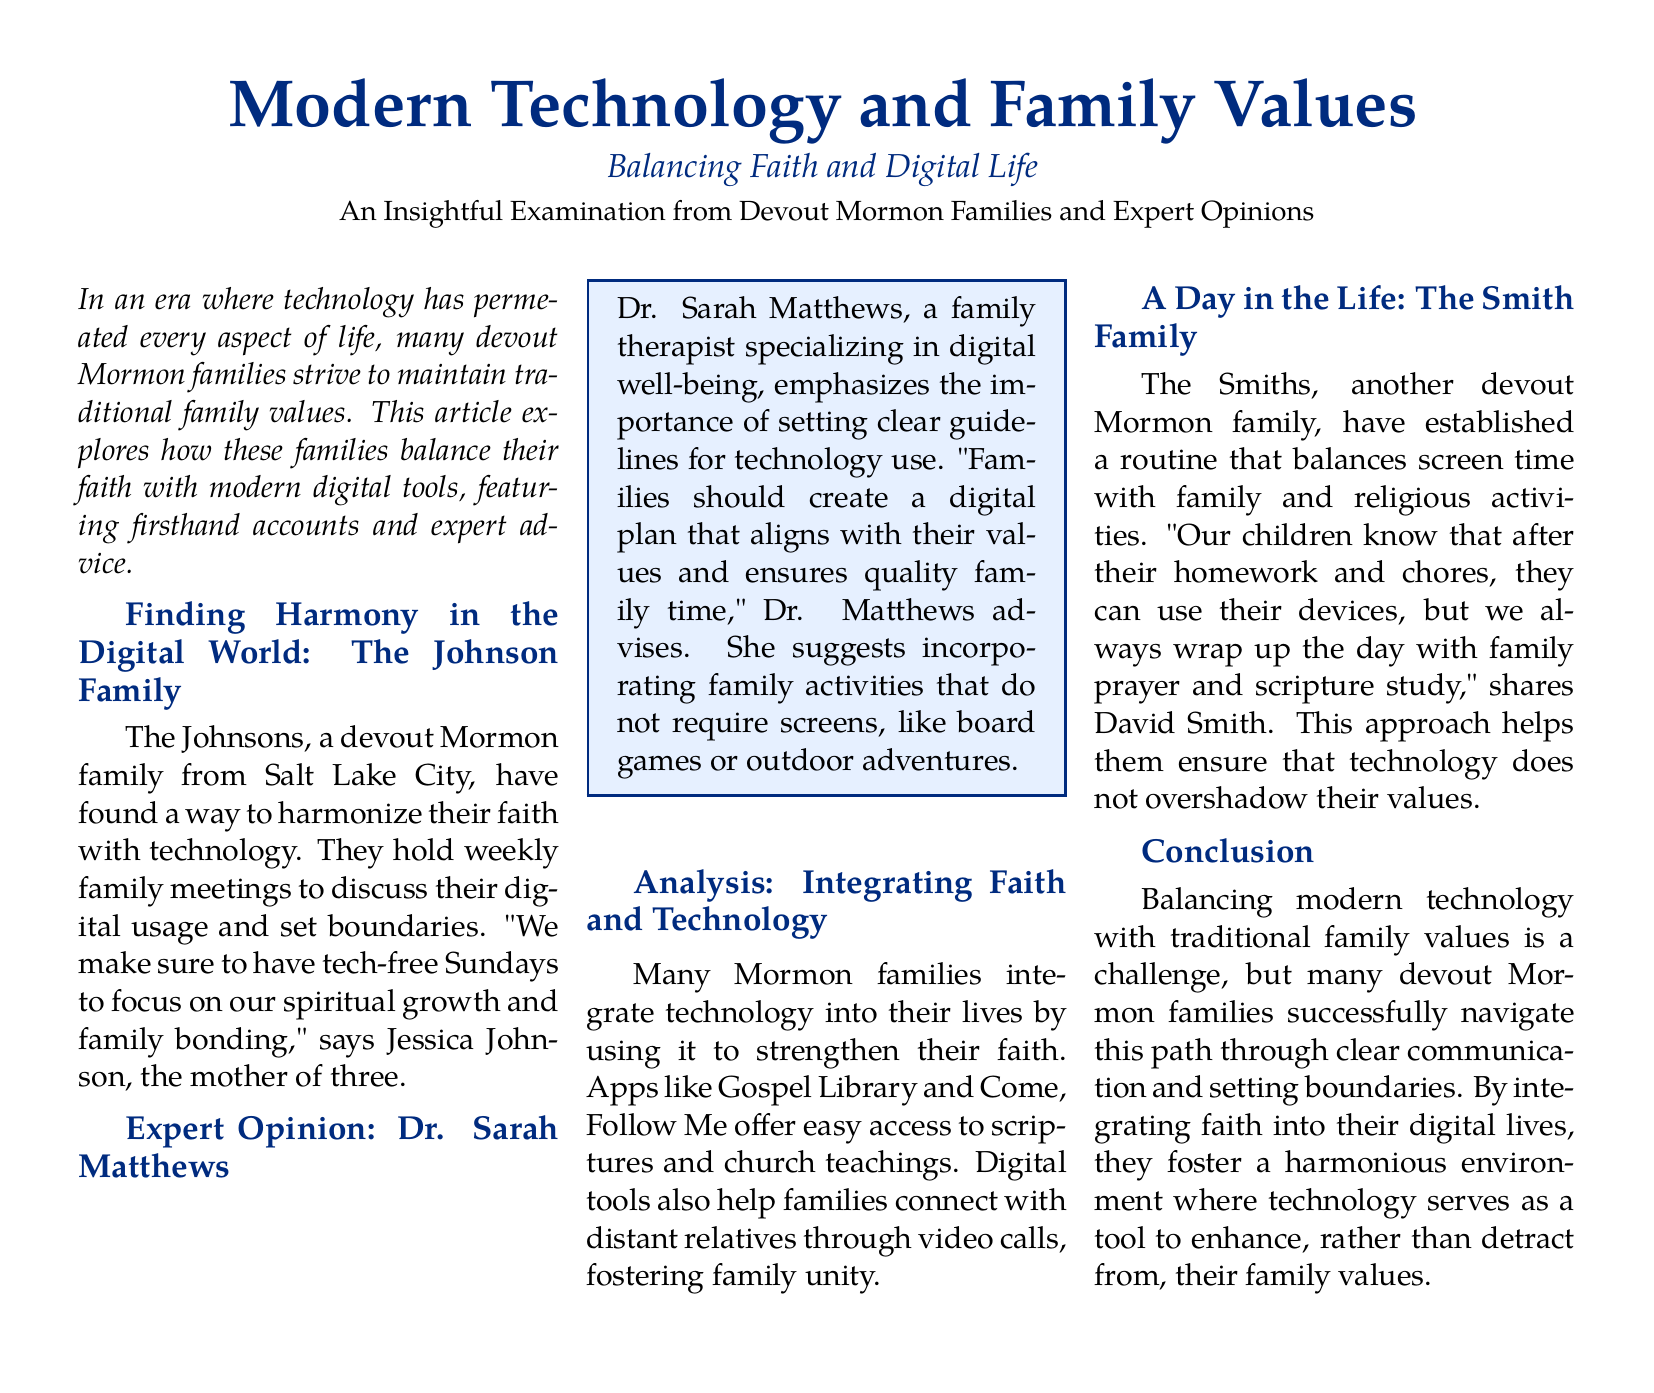What is the title of the article? The title is prominently displayed at the top of the document, which is "Modern Technology and Family Values."
Answer: Modern Technology and Family Values Who is featured in the personal story about balancing tech use? The Johnson family is highlighted in the article as an example of a devout Mormon family balancing technology and values.
Answer: The Johnson Family What specific day do the Johnsons avoid technology? The article mentions that the Johnsons have tech-free Sundays for spiritual and family bonding.
Answer: Sundays Which expert contributed an opinion in the article? Dr. Sarah Matthews is cited as an expert providing insights on digital well-being for families.
Answer: Dr. Sarah Matthews What kind of activities does Dr. Matthews suggest for family time? The expert advises engaging in activities that do not require screens, like board games or outdoor adventures.
Answer: Board games or outdoor adventures What is the routine established by the Smith family regarding technology? The Smith family has a routine that includes completing homework and chores before screen time, followed by family prayer and scripture study.
Answer: Family prayer and scripture study What does the article conclude about balancing technology and family values? The conclusion emphasizes that many devout Mormon families navigate this balance through communication and boundaries.
Answer: Communication and boundaries Which tools are mentioned that help families connect with their faith? The article lists apps like "Gospel Library" and "Come, Follow Me" as tools that aid in accessing scriptures and church teachings.
Answer: Gospel Library and Come, Follow Me What is the overall theme of the article? The article discusses the integration of modern technology with traditional family values within devout Mormon families.
Answer: Integration of modern technology with traditional family values 